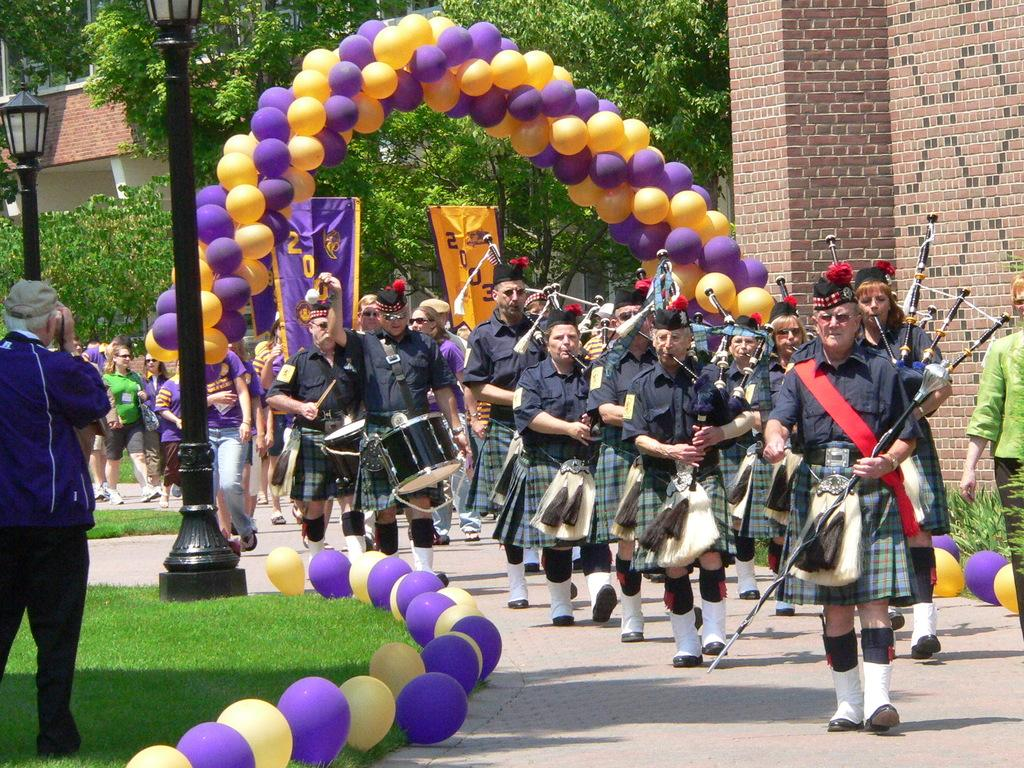What is happening in the image involving a group of people? In the image, there is a group of people, and some of them are playing musical instruments. What are the people in the group doing? The people are walking. What objects can be seen in the image besides the people? There are poles, lights, and trees visible in the image. What additional items are present in the image? There are balloons in the image. Can you tell me how many goats are present in the image? There are no goats present in the image. What type of can is visible in the image? There is no can present in the image. 